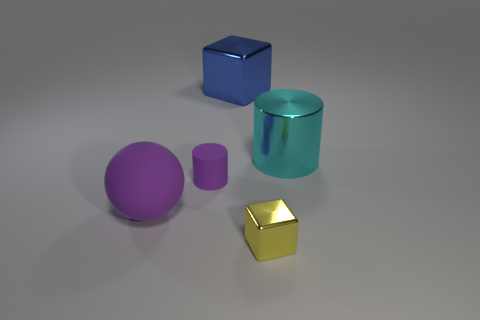There is a yellow shiny object; is its size the same as the thing right of the tiny block?
Provide a succinct answer. No. There is a purple thing right of the matte object that is in front of the purple rubber cylinder; are there any large blue metal objects that are behind it?
Your answer should be compact. Yes. There is a purple object that is in front of the purple rubber object behind the purple ball; what is its material?
Give a very brief answer. Rubber. What is the material of the thing that is both on the right side of the large block and behind the small purple thing?
Your answer should be very brief. Metal. Are there any other cyan objects that have the same shape as the small rubber thing?
Offer a terse response. Yes. Are there any objects that are in front of the large metal thing that is on the right side of the yellow block?
Keep it short and to the point. Yes. What number of cyan cylinders have the same material as the small purple cylinder?
Offer a terse response. 0. Are there any small brown rubber cubes?
Your answer should be very brief. No. What number of matte balls have the same color as the tiny cylinder?
Provide a short and direct response. 1. Are the big cyan object and the block that is behind the large purple ball made of the same material?
Your answer should be very brief. Yes. 